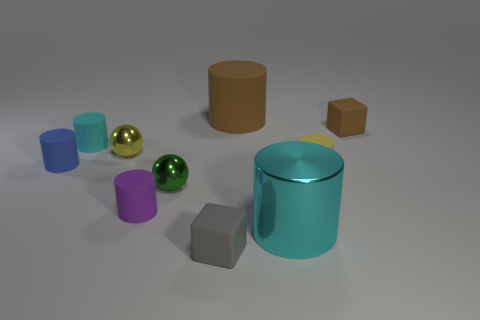What color is the rubber block left of the big brown matte thing?
Provide a short and direct response. Gray. Is there a small shiny object in front of the big object that is behind the cube that is behind the tiny blue rubber thing?
Ensure brevity in your answer.  Yes. Is the number of small yellow objects right of the green metallic object greater than the number of red cylinders?
Provide a short and direct response. Yes. There is a blue thing behind the small gray matte thing; does it have the same shape as the small brown matte thing?
Provide a short and direct response. No. How many objects are either blue objects or rubber cubes that are in front of the brown rubber block?
Make the answer very short. 2. There is a object that is both behind the tiny cyan rubber cylinder and on the left side of the large metallic cylinder; what size is it?
Offer a terse response. Large. Are there more tiny cyan things to the right of the small gray object than tiny green shiny things on the left side of the cyan matte cylinder?
Offer a terse response. No. There is a small blue rubber object; is its shape the same as the purple matte object that is left of the gray cube?
Keep it short and to the point. Yes. What number of other objects are the same shape as the gray rubber thing?
Ensure brevity in your answer.  1. What is the color of the cylinder that is on the right side of the brown matte cylinder and behind the small purple object?
Make the answer very short. Yellow. 